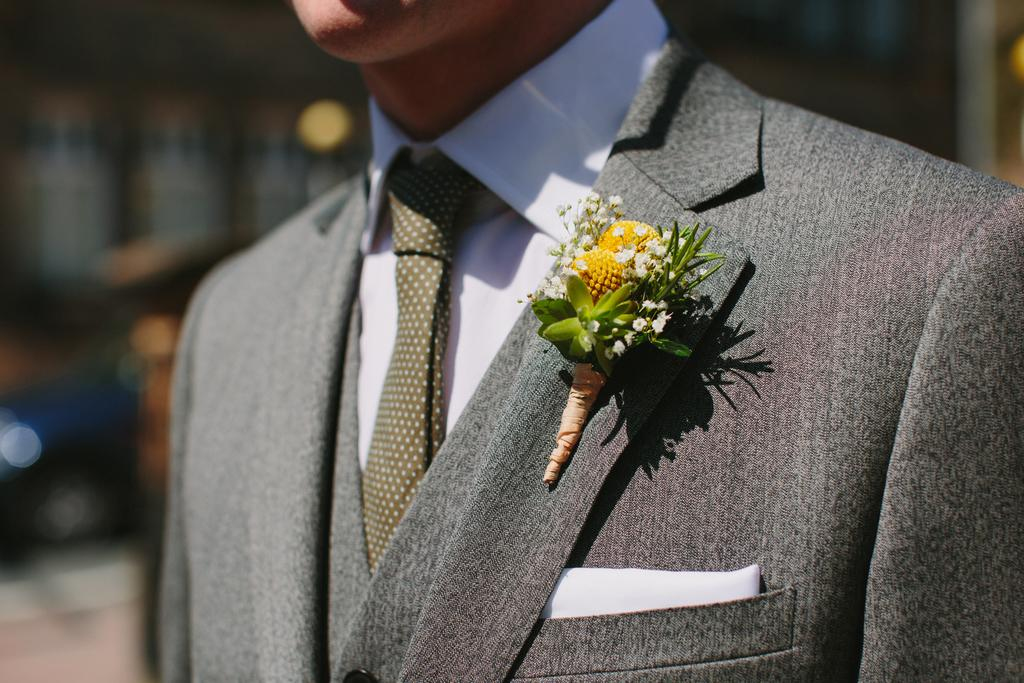What is the main subject of the image? There is a man in the image. What is the man wearing? The man is wearing a grey suit, a white shirt, and a tie. Can you describe any additional details about the man's outfit? Yes, there is a small flower on the suit. What can be said about the background of the image? The background of the image is blurry. How many rooms can be seen in the image? There are no rooms visible in the image; it features a man wearing a suit with a small flower. What type of heart-related activity is the man engaged in within the image? There is no heart-related activity depicted in the image; it focuses on the man's outfit and the blurry background. 